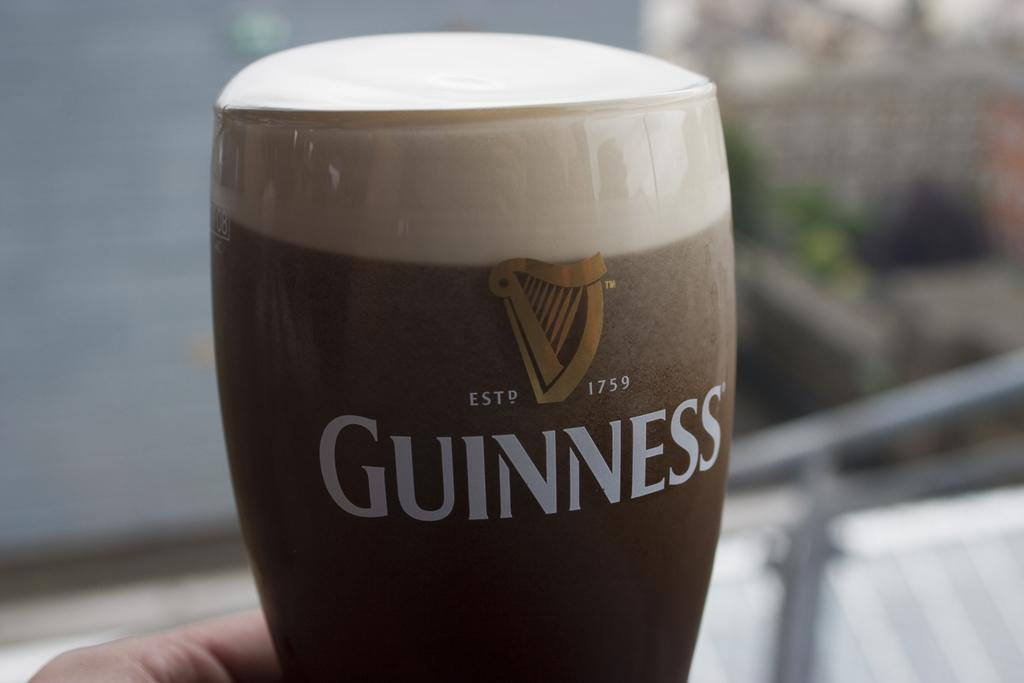What is the main subject of the image? There is a person in the image. What is the person holding in the image? The person is holding a glass. What is inside the glass? The glass contains some liquid. What part of the person is visible in the image? Only the person's hand is visible. How would you describe the background of the image? The background of the image is blurred. What type of design is featured on the holiday card in the image? There is no holiday card present in the image. Can you tell me the date of the person's birth from the image? There is no information about the person's birth in the image. 